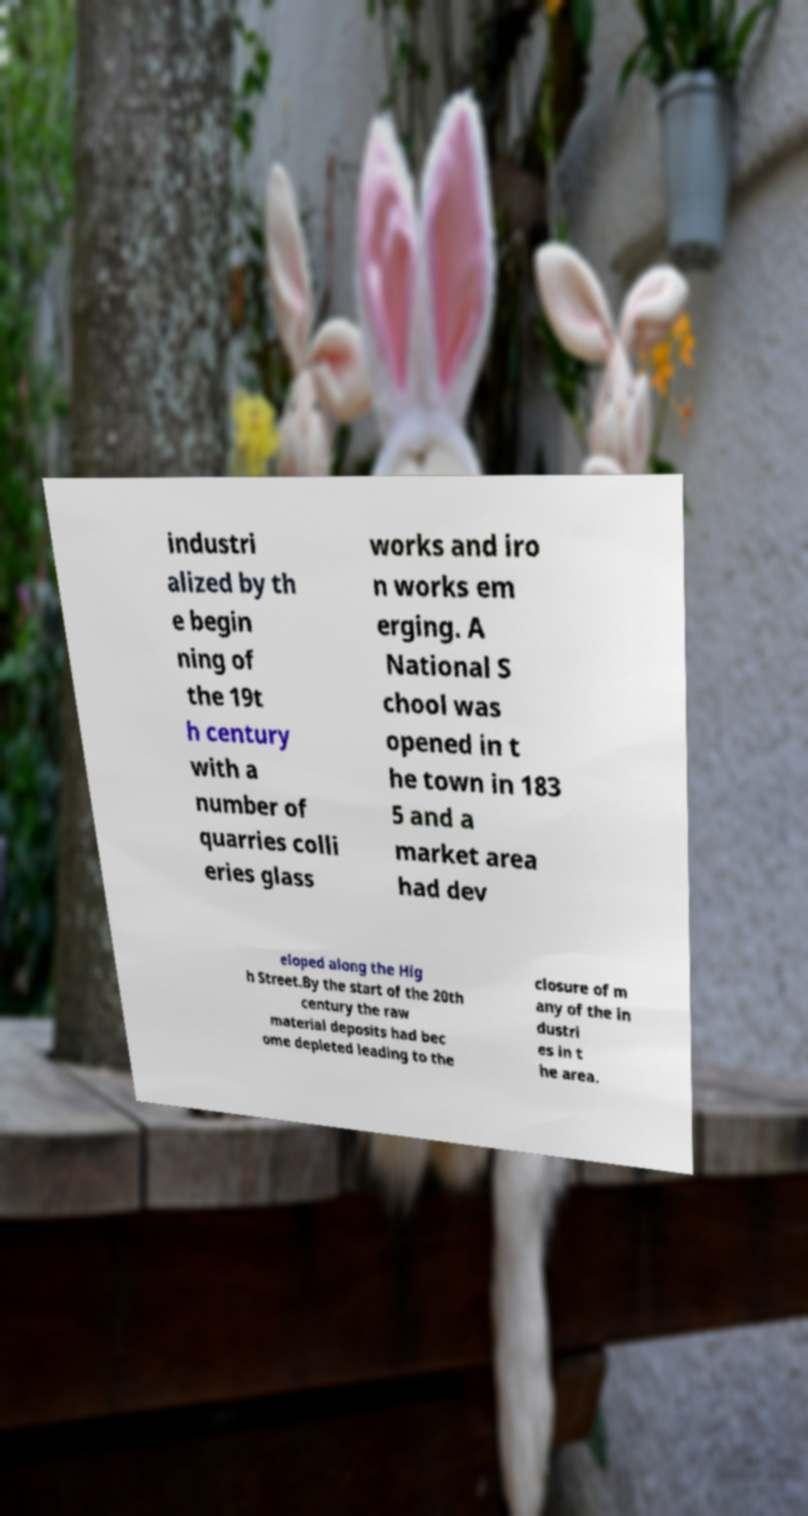Can you accurately transcribe the text from the provided image for me? industri alized by th e begin ning of the 19t h century with a number of quarries colli eries glass works and iro n works em erging. A National S chool was opened in t he town in 183 5 and a market area had dev eloped along the Hig h Street.By the start of the 20th century the raw material deposits had bec ome depleted leading to the closure of m any of the in dustri es in t he area. 